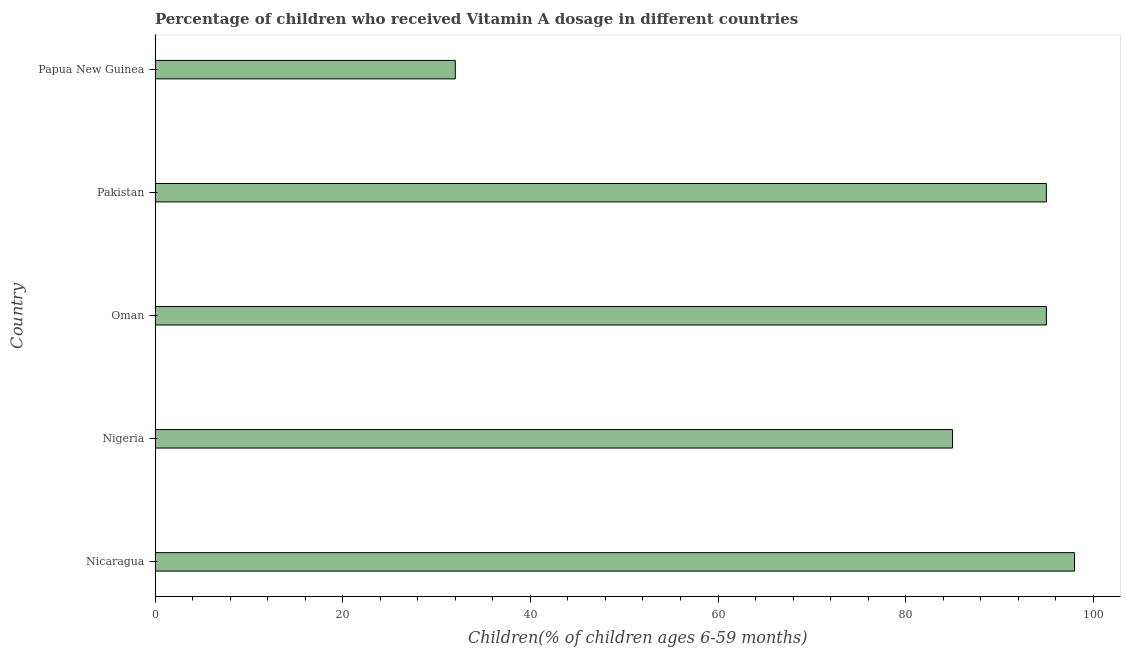What is the title of the graph?
Your answer should be compact. Percentage of children who received Vitamin A dosage in different countries. What is the label or title of the X-axis?
Offer a terse response. Children(% of children ages 6-59 months). Across all countries, what is the maximum vitamin a supplementation coverage rate?
Offer a very short reply. 98. In which country was the vitamin a supplementation coverage rate maximum?
Keep it short and to the point. Nicaragua. In which country was the vitamin a supplementation coverage rate minimum?
Offer a very short reply. Papua New Guinea. What is the sum of the vitamin a supplementation coverage rate?
Offer a terse response. 405. In how many countries, is the vitamin a supplementation coverage rate greater than 92 %?
Offer a very short reply. 3. What is the ratio of the vitamin a supplementation coverage rate in Nicaragua to that in Papua New Guinea?
Your response must be concise. 3.06. Is the vitamin a supplementation coverage rate in Nigeria less than that in Pakistan?
Keep it short and to the point. Yes. Is the sum of the vitamin a supplementation coverage rate in Pakistan and Papua New Guinea greater than the maximum vitamin a supplementation coverage rate across all countries?
Offer a terse response. Yes. In how many countries, is the vitamin a supplementation coverage rate greater than the average vitamin a supplementation coverage rate taken over all countries?
Provide a short and direct response. 4. How many countries are there in the graph?
Keep it short and to the point. 5. What is the difference between two consecutive major ticks on the X-axis?
Keep it short and to the point. 20. What is the Children(% of children ages 6-59 months) in Nigeria?
Make the answer very short. 85. What is the Children(% of children ages 6-59 months) in Pakistan?
Give a very brief answer. 95. What is the Children(% of children ages 6-59 months) in Papua New Guinea?
Provide a succinct answer. 32. What is the difference between the Children(% of children ages 6-59 months) in Nicaragua and Nigeria?
Your answer should be very brief. 13. What is the difference between the Children(% of children ages 6-59 months) in Nicaragua and Oman?
Give a very brief answer. 3. What is the difference between the Children(% of children ages 6-59 months) in Nigeria and Papua New Guinea?
Ensure brevity in your answer.  53. What is the difference between the Children(% of children ages 6-59 months) in Oman and Pakistan?
Ensure brevity in your answer.  0. What is the difference between the Children(% of children ages 6-59 months) in Oman and Papua New Guinea?
Provide a short and direct response. 63. What is the ratio of the Children(% of children ages 6-59 months) in Nicaragua to that in Nigeria?
Your response must be concise. 1.15. What is the ratio of the Children(% of children ages 6-59 months) in Nicaragua to that in Oman?
Keep it short and to the point. 1.03. What is the ratio of the Children(% of children ages 6-59 months) in Nicaragua to that in Pakistan?
Your answer should be compact. 1.03. What is the ratio of the Children(% of children ages 6-59 months) in Nicaragua to that in Papua New Guinea?
Offer a terse response. 3.06. What is the ratio of the Children(% of children ages 6-59 months) in Nigeria to that in Oman?
Offer a terse response. 0.9. What is the ratio of the Children(% of children ages 6-59 months) in Nigeria to that in Pakistan?
Your answer should be very brief. 0.9. What is the ratio of the Children(% of children ages 6-59 months) in Nigeria to that in Papua New Guinea?
Make the answer very short. 2.66. What is the ratio of the Children(% of children ages 6-59 months) in Oman to that in Papua New Guinea?
Offer a very short reply. 2.97. What is the ratio of the Children(% of children ages 6-59 months) in Pakistan to that in Papua New Guinea?
Provide a short and direct response. 2.97. 